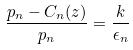Convert formula to latex. <formula><loc_0><loc_0><loc_500><loc_500>\frac { p _ { n } - C _ { n } ( z ) } { p _ { n } } = \frac { k } { \epsilon _ { n } }</formula> 